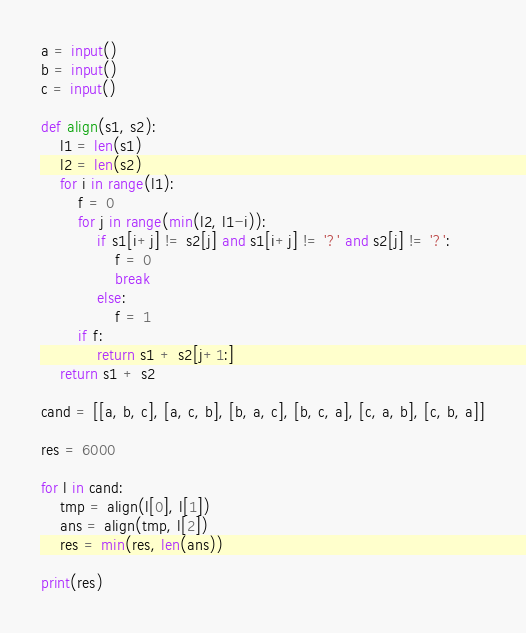Convert code to text. <code><loc_0><loc_0><loc_500><loc_500><_Python_>a = input()
b = input()
c = input()

def align(s1, s2):
    l1 = len(s1)
    l2 = len(s2)
    for i in range(l1):
        f = 0
        for j in range(min(l2, l1-i)):
            if s1[i+j] != s2[j] and s1[i+j] != '?' and s2[j] != '?':
                f = 0
                break
            else:
                f = 1
        if f:
            return s1 + s2[j+1:]
    return s1 + s2

cand = [[a, b, c], [a, c, b], [b, a, c], [b, c, a], [c, a, b], [c, b, a]]

res = 6000

for l in cand:
    tmp = align(l[0], l[1])
    ans = align(tmp, l[2])
    res = min(res, len(ans))

print(res)
</code> 